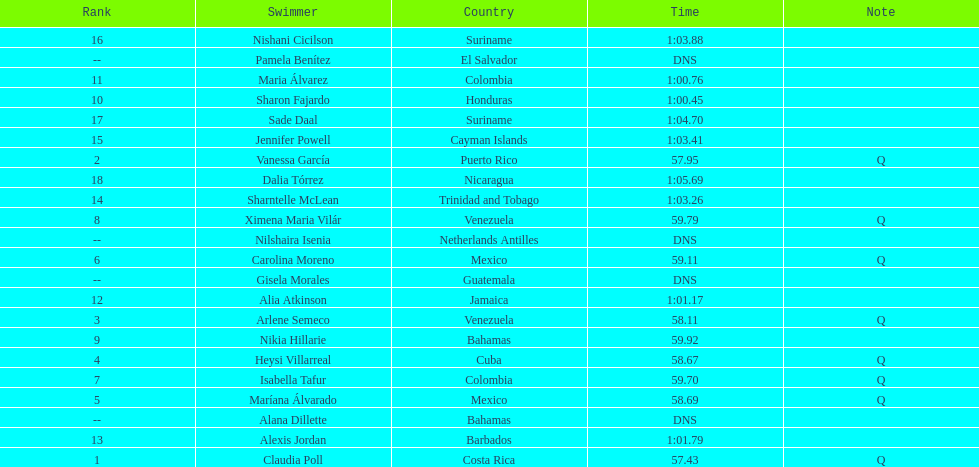Which swimmer had the longest time? Dalia Tórrez. 